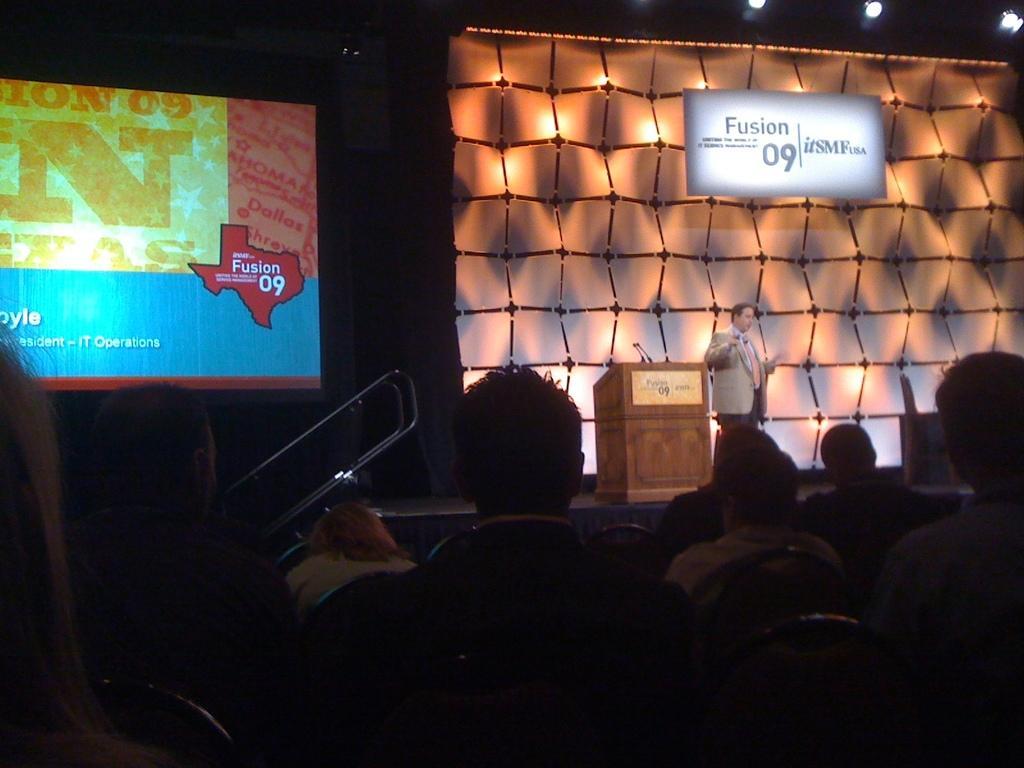Please provide a concise description of this image. In the image there is a man in brown suit standing on stage, there are lights on the wall, on the left side there is a screen, in the front there are many people sitting on chairs and looking at the stage. 